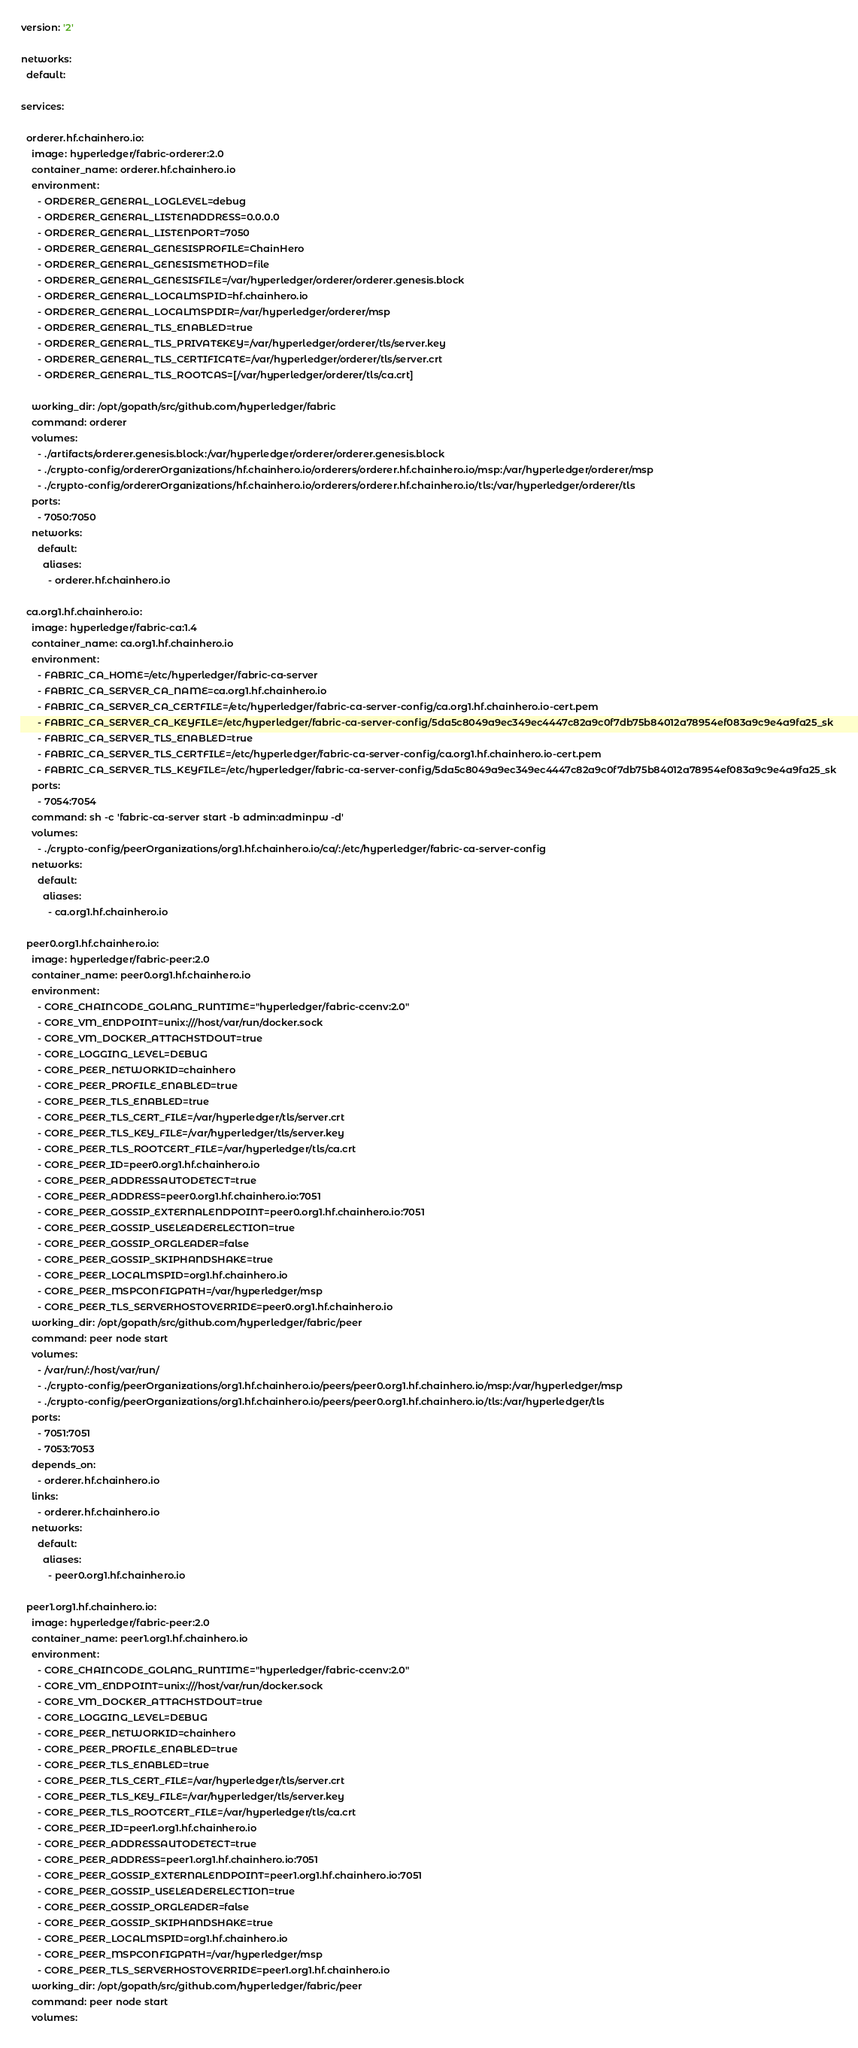Convert code to text. <code><loc_0><loc_0><loc_500><loc_500><_YAML_>version: '2'

networks:
  default:

services:

  orderer.hf.chainhero.io:
    image: hyperledger/fabric-orderer:2.0
    container_name: orderer.hf.chainhero.io
    environment:
      - ORDERER_GENERAL_LOGLEVEL=debug
      - ORDERER_GENERAL_LISTENADDRESS=0.0.0.0
      - ORDERER_GENERAL_LISTENPORT=7050
      - ORDERER_GENERAL_GENESISPROFILE=ChainHero
      - ORDERER_GENERAL_GENESISMETHOD=file
      - ORDERER_GENERAL_GENESISFILE=/var/hyperledger/orderer/orderer.genesis.block
      - ORDERER_GENERAL_LOCALMSPID=hf.chainhero.io
      - ORDERER_GENERAL_LOCALMSPDIR=/var/hyperledger/orderer/msp
      - ORDERER_GENERAL_TLS_ENABLED=true
      - ORDERER_GENERAL_TLS_PRIVATEKEY=/var/hyperledger/orderer/tls/server.key
      - ORDERER_GENERAL_TLS_CERTIFICATE=/var/hyperledger/orderer/tls/server.crt
      - ORDERER_GENERAL_TLS_ROOTCAS=[/var/hyperledger/orderer/tls/ca.crt]

    working_dir: /opt/gopath/src/github.com/hyperledger/fabric
    command: orderer
    volumes:
      - ./artifacts/orderer.genesis.block:/var/hyperledger/orderer/orderer.genesis.block
      - ./crypto-config/ordererOrganizations/hf.chainhero.io/orderers/orderer.hf.chainhero.io/msp:/var/hyperledger/orderer/msp
      - ./crypto-config/ordererOrganizations/hf.chainhero.io/orderers/orderer.hf.chainhero.io/tls:/var/hyperledger/orderer/tls
    ports:
      - 7050:7050
    networks:
      default:
        aliases:
          - orderer.hf.chainhero.io

  ca.org1.hf.chainhero.io:
    image: hyperledger/fabric-ca:1.4
    container_name: ca.org1.hf.chainhero.io
    environment:
      - FABRIC_CA_HOME=/etc/hyperledger/fabric-ca-server
      - FABRIC_CA_SERVER_CA_NAME=ca.org1.hf.chainhero.io
      - FABRIC_CA_SERVER_CA_CERTFILE=/etc/hyperledger/fabric-ca-server-config/ca.org1.hf.chainhero.io-cert.pem
      - FABRIC_CA_SERVER_CA_KEYFILE=/etc/hyperledger/fabric-ca-server-config/5da5c8049a9ec349ec4447c82a9c0f7db75b84012a78954ef083a9c9e4a9fa25_sk
      - FABRIC_CA_SERVER_TLS_ENABLED=true
      - FABRIC_CA_SERVER_TLS_CERTFILE=/etc/hyperledger/fabric-ca-server-config/ca.org1.hf.chainhero.io-cert.pem
      - FABRIC_CA_SERVER_TLS_KEYFILE=/etc/hyperledger/fabric-ca-server-config/5da5c8049a9ec349ec4447c82a9c0f7db75b84012a78954ef083a9c9e4a9fa25_sk
    ports:
      - 7054:7054
    command: sh -c 'fabric-ca-server start -b admin:adminpw -d'
    volumes:
      - ./crypto-config/peerOrganizations/org1.hf.chainhero.io/ca/:/etc/hyperledger/fabric-ca-server-config
    networks:
      default:
        aliases:
          - ca.org1.hf.chainhero.io

  peer0.org1.hf.chainhero.io:
    image: hyperledger/fabric-peer:2.0
    container_name: peer0.org1.hf.chainhero.io
    environment:
      - CORE_CHAINCODE_GOLANG_RUNTIME="hyperledger/fabric-ccenv:2.0"
      - CORE_VM_ENDPOINT=unix:///host/var/run/docker.sock
      - CORE_VM_DOCKER_ATTACHSTDOUT=true
      - CORE_LOGGING_LEVEL=DEBUG
      - CORE_PEER_NETWORKID=chainhero
      - CORE_PEER_PROFILE_ENABLED=true
      - CORE_PEER_TLS_ENABLED=true
      - CORE_PEER_TLS_CERT_FILE=/var/hyperledger/tls/server.crt
      - CORE_PEER_TLS_KEY_FILE=/var/hyperledger/tls/server.key
      - CORE_PEER_TLS_ROOTCERT_FILE=/var/hyperledger/tls/ca.crt
      - CORE_PEER_ID=peer0.org1.hf.chainhero.io
      - CORE_PEER_ADDRESSAUTODETECT=true
      - CORE_PEER_ADDRESS=peer0.org1.hf.chainhero.io:7051
      - CORE_PEER_GOSSIP_EXTERNALENDPOINT=peer0.org1.hf.chainhero.io:7051
      - CORE_PEER_GOSSIP_USELEADERELECTION=true
      - CORE_PEER_GOSSIP_ORGLEADER=false
      - CORE_PEER_GOSSIP_SKIPHANDSHAKE=true
      - CORE_PEER_LOCALMSPID=org1.hf.chainhero.io
      - CORE_PEER_MSPCONFIGPATH=/var/hyperledger/msp
      - CORE_PEER_TLS_SERVERHOSTOVERRIDE=peer0.org1.hf.chainhero.io
    working_dir: /opt/gopath/src/github.com/hyperledger/fabric/peer
    command: peer node start
    volumes:
      - /var/run/:/host/var/run/
      - ./crypto-config/peerOrganizations/org1.hf.chainhero.io/peers/peer0.org1.hf.chainhero.io/msp:/var/hyperledger/msp
      - ./crypto-config/peerOrganizations/org1.hf.chainhero.io/peers/peer0.org1.hf.chainhero.io/tls:/var/hyperledger/tls
    ports:
      - 7051:7051
      - 7053:7053
    depends_on:
      - orderer.hf.chainhero.io
    links:
      - orderer.hf.chainhero.io
    networks:
      default:
        aliases:
          - peer0.org1.hf.chainhero.io

  peer1.org1.hf.chainhero.io:
    image: hyperledger/fabric-peer:2.0
    container_name: peer1.org1.hf.chainhero.io
    environment:
      - CORE_CHAINCODE_GOLANG_RUNTIME="hyperledger/fabric-ccenv:2.0"
      - CORE_VM_ENDPOINT=unix:///host/var/run/docker.sock
      - CORE_VM_DOCKER_ATTACHSTDOUT=true
      - CORE_LOGGING_LEVEL=DEBUG
      - CORE_PEER_NETWORKID=chainhero
      - CORE_PEER_PROFILE_ENABLED=true
      - CORE_PEER_TLS_ENABLED=true
      - CORE_PEER_TLS_CERT_FILE=/var/hyperledger/tls/server.crt
      - CORE_PEER_TLS_KEY_FILE=/var/hyperledger/tls/server.key
      - CORE_PEER_TLS_ROOTCERT_FILE=/var/hyperledger/tls/ca.crt
      - CORE_PEER_ID=peer1.org1.hf.chainhero.io
      - CORE_PEER_ADDRESSAUTODETECT=true
      - CORE_PEER_ADDRESS=peer1.org1.hf.chainhero.io:7051
      - CORE_PEER_GOSSIP_EXTERNALENDPOINT=peer1.org1.hf.chainhero.io:7051
      - CORE_PEER_GOSSIP_USELEADERELECTION=true
      - CORE_PEER_GOSSIP_ORGLEADER=false
      - CORE_PEER_GOSSIP_SKIPHANDSHAKE=true
      - CORE_PEER_LOCALMSPID=org1.hf.chainhero.io
      - CORE_PEER_MSPCONFIGPATH=/var/hyperledger/msp
      - CORE_PEER_TLS_SERVERHOSTOVERRIDE=peer1.org1.hf.chainhero.io
    working_dir: /opt/gopath/src/github.com/hyperledger/fabric/peer
    command: peer node start
    volumes:</code> 